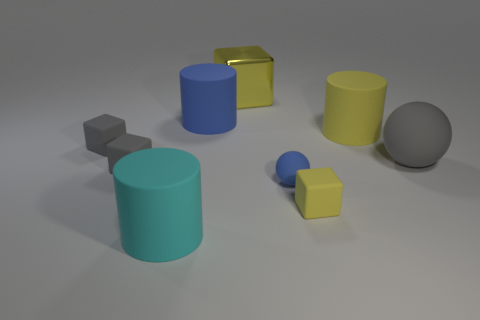Is there anything else that has the same material as the large yellow block?
Offer a terse response. No. Are there any brown things?
Your answer should be compact. No. There is a cylinder that is behind the cyan matte cylinder and to the left of the small yellow cube; what size is it?
Make the answer very short. Large. Is the number of tiny gray rubber things left of the big yellow rubber cylinder greater than the number of large blue rubber objects behind the large blue thing?
Keep it short and to the point. Yes. What is the size of the matte cylinder that is the same color as the large cube?
Provide a succinct answer. Large. The big sphere is what color?
Your answer should be compact. Gray. There is a big object that is left of the big yellow metallic cube and behind the yellow cylinder; what is its color?
Your answer should be compact. Blue. The big cylinder that is right of the small block that is right of the big rubber thing on the left side of the large blue rubber cylinder is what color?
Your answer should be compact. Yellow. The rubber sphere that is the same size as the metallic block is what color?
Provide a succinct answer. Gray. There is a yellow thing that is behind the large rubber cylinder right of the matte block that is on the right side of the small blue thing; what shape is it?
Offer a very short reply. Cube. 